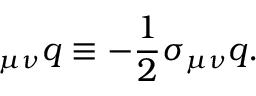Convert formula to latex. <formula><loc_0><loc_0><loc_500><loc_500>{ \Sigma } _ { \mu \nu } q \equiv - \frac { 1 } { 2 } \sigma _ { \mu \nu } q .</formula> 